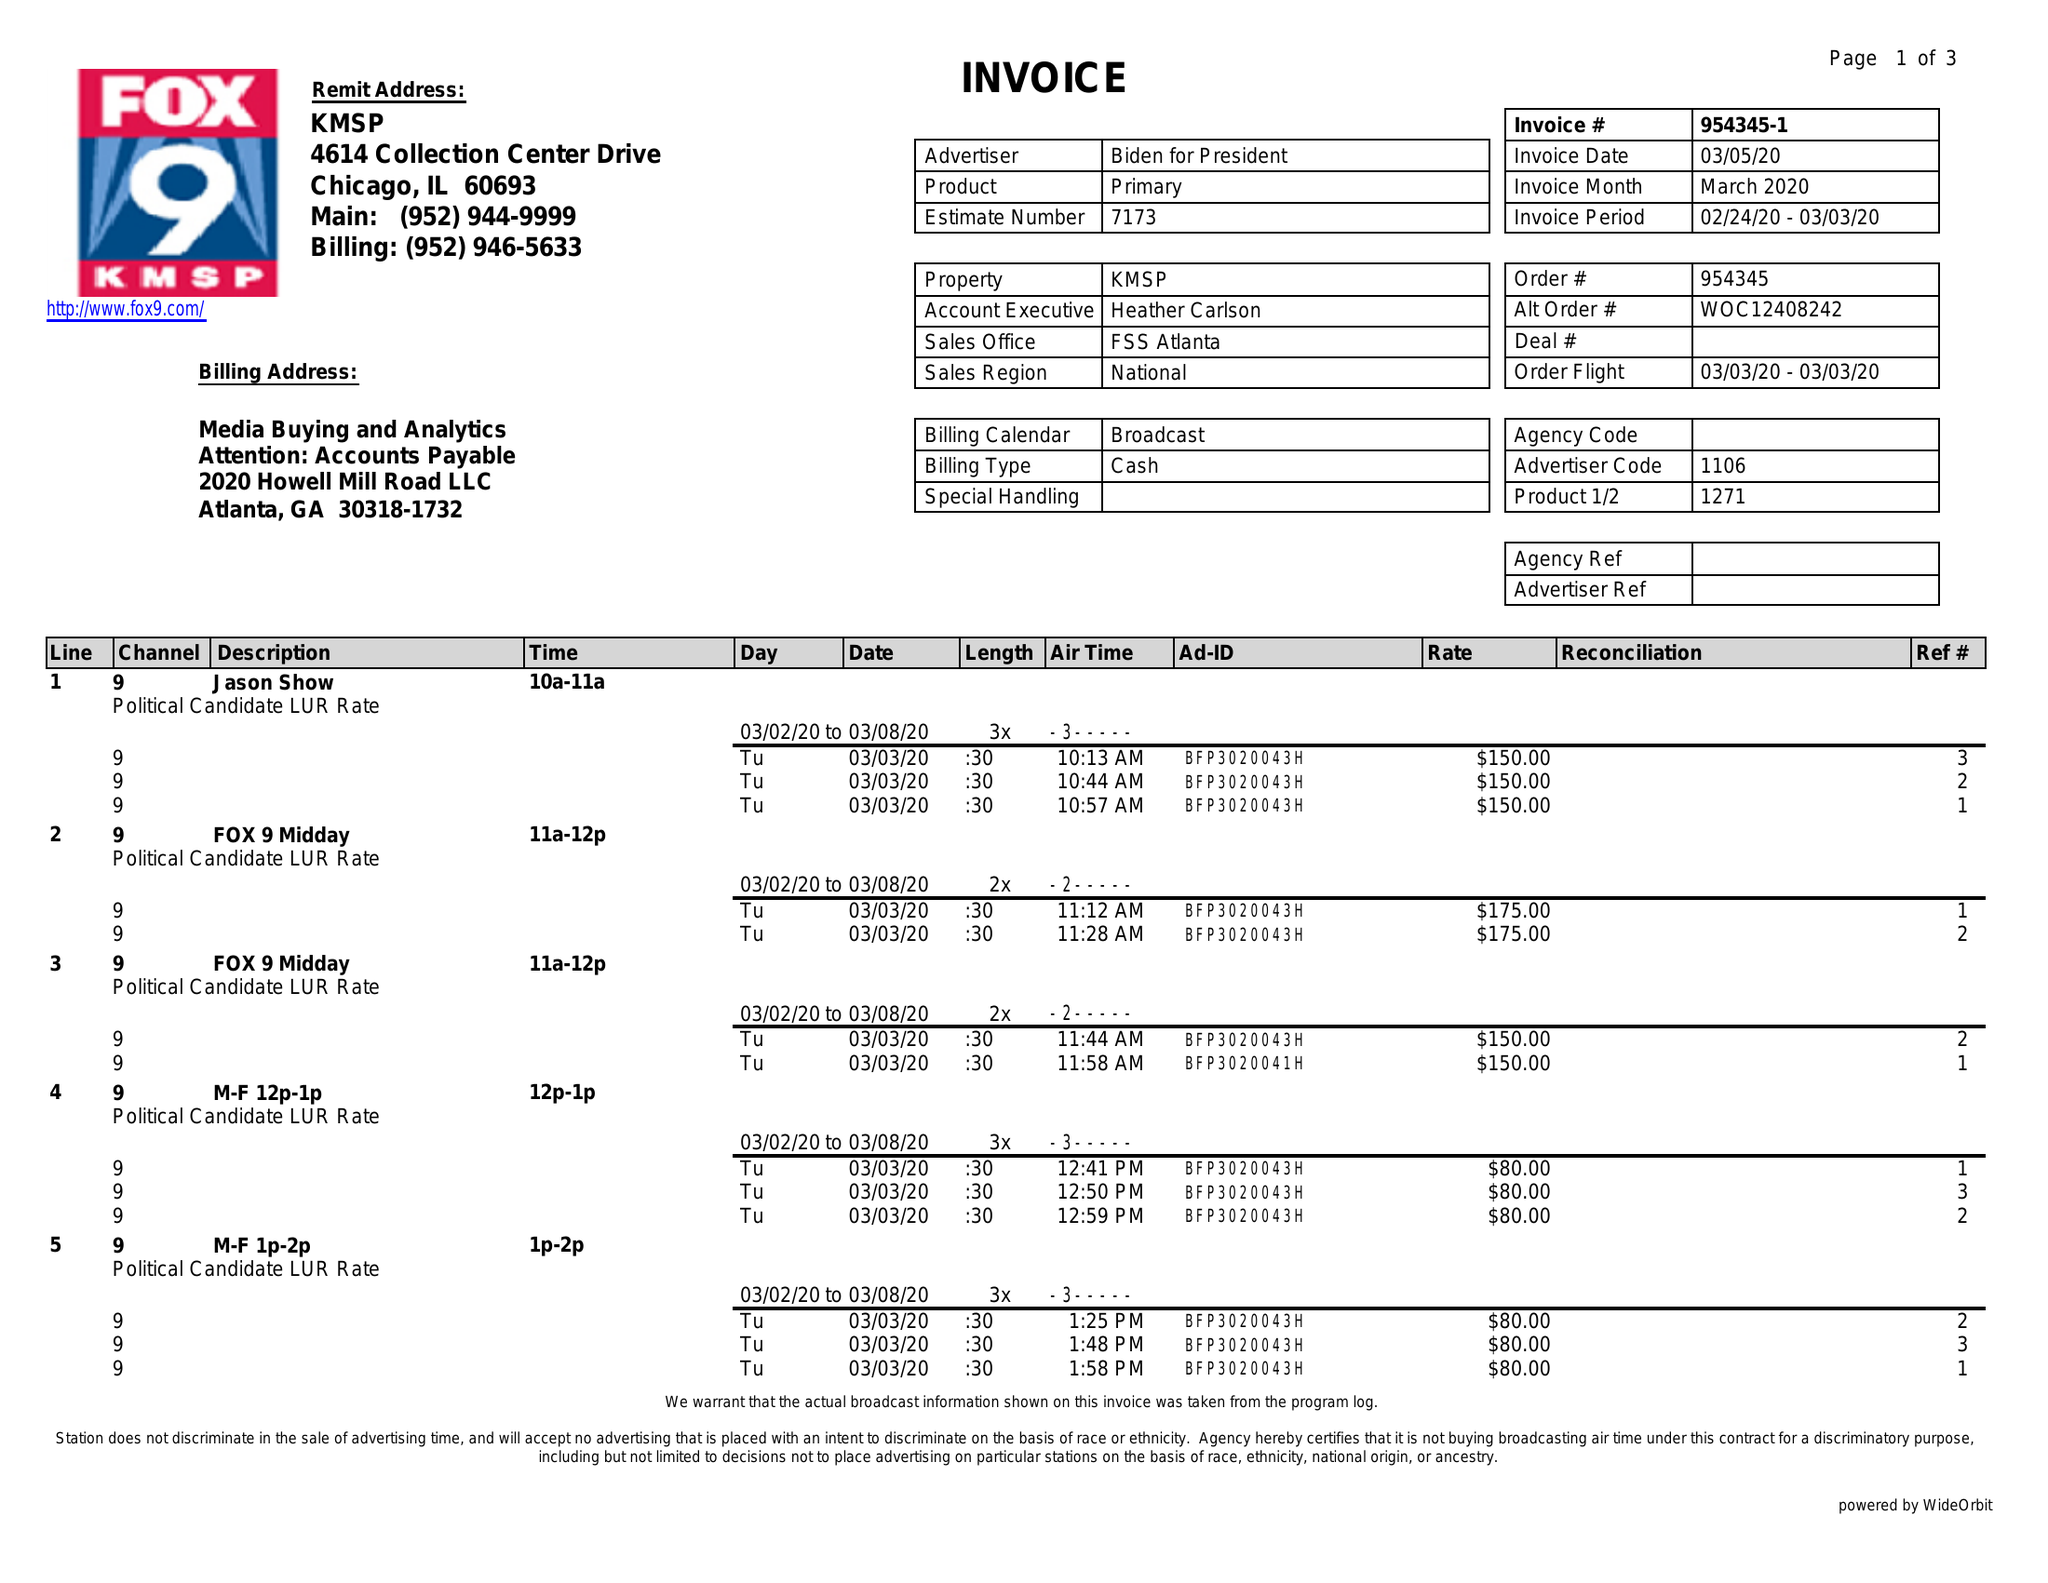What is the value for the advertiser?
Answer the question using a single word or phrase. BIDEN FOR PRESIDENT 